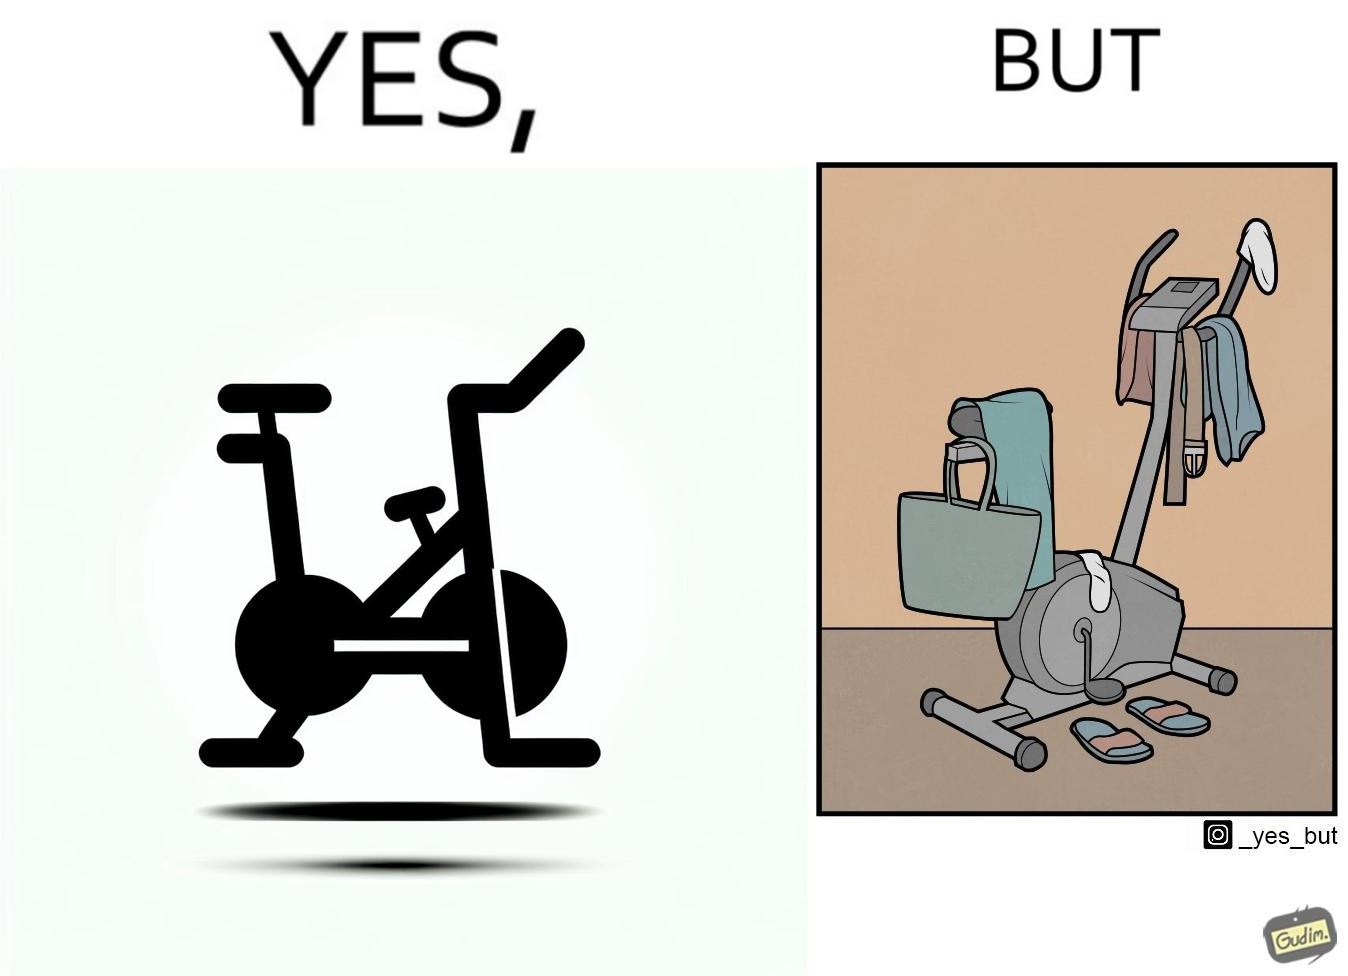What is the satirical meaning behind this image? The images are funny since they show an exercise bike has been bought but is not being used for its purpose, that is, exercising. It is rather being used to hang clothes, bags and other items 